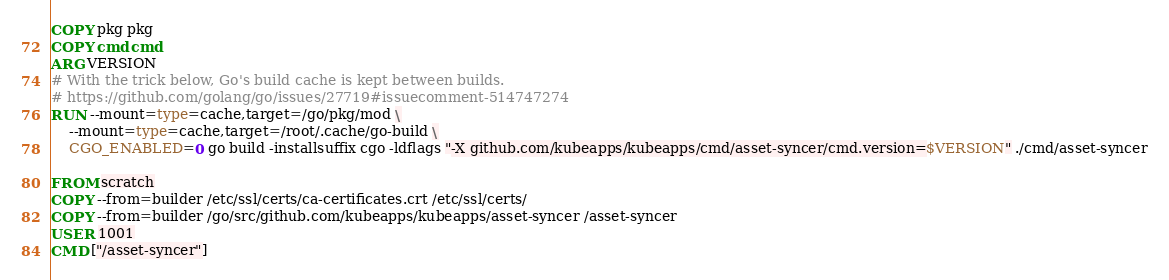Convert code to text. <code><loc_0><loc_0><loc_500><loc_500><_Dockerfile_>COPY pkg pkg
COPY cmd cmd
ARG VERSION
# With the trick below, Go's build cache is kept between builds.
# https://github.com/golang/go/issues/27719#issuecomment-514747274
RUN --mount=type=cache,target=/go/pkg/mod \
    --mount=type=cache,target=/root/.cache/go-build \
    CGO_ENABLED=0 go build -installsuffix cgo -ldflags "-X github.com/kubeapps/kubeapps/cmd/asset-syncer/cmd.version=$VERSION" ./cmd/asset-syncer

FROM scratch
COPY --from=builder /etc/ssl/certs/ca-certificates.crt /etc/ssl/certs/
COPY --from=builder /go/src/github.com/kubeapps/kubeapps/asset-syncer /asset-syncer
USER 1001
CMD ["/asset-syncer"]
</code> 